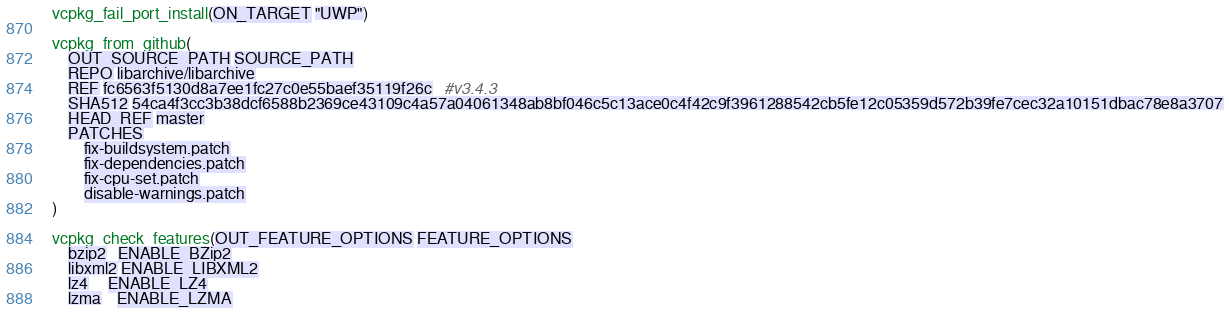<code> <loc_0><loc_0><loc_500><loc_500><_CMake_>vcpkg_fail_port_install(ON_TARGET "UWP")

vcpkg_from_github(
    OUT_SOURCE_PATH SOURCE_PATH
    REPO libarchive/libarchive
    REF fc6563f5130d8a7ee1fc27c0e55baef35119f26c   #v3.4.3
    SHA512 54ca4f3cc3b38dcf6588b2369ce43109c4a57a04061348ab8bf046c5c13ace0c4f42c9f3961288542cb5fe12c05359d572b39fe7cec32a10151dbac78e8a3707
    HEAD_REF master
    PATCHES
        fix-buildsystem.patch
        fix-dependencies.patch
        fix-cpu-set.patch
        disable-warnings.patch
)

vcpkg_check_features(OUT_FEATURE_OPTIONS FEATURE_OPTIONS
    bzip2   ENABLE_BZip2
    libxml2 ENABLE_LIBXML2
    lz4     ENABLE_LZ4
    lzma    ENABLE_LZMA</code> 